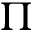Convert formula to latex. <formula><loc_0><loc_0><loc_500><loc_500>\Pi</formula> 